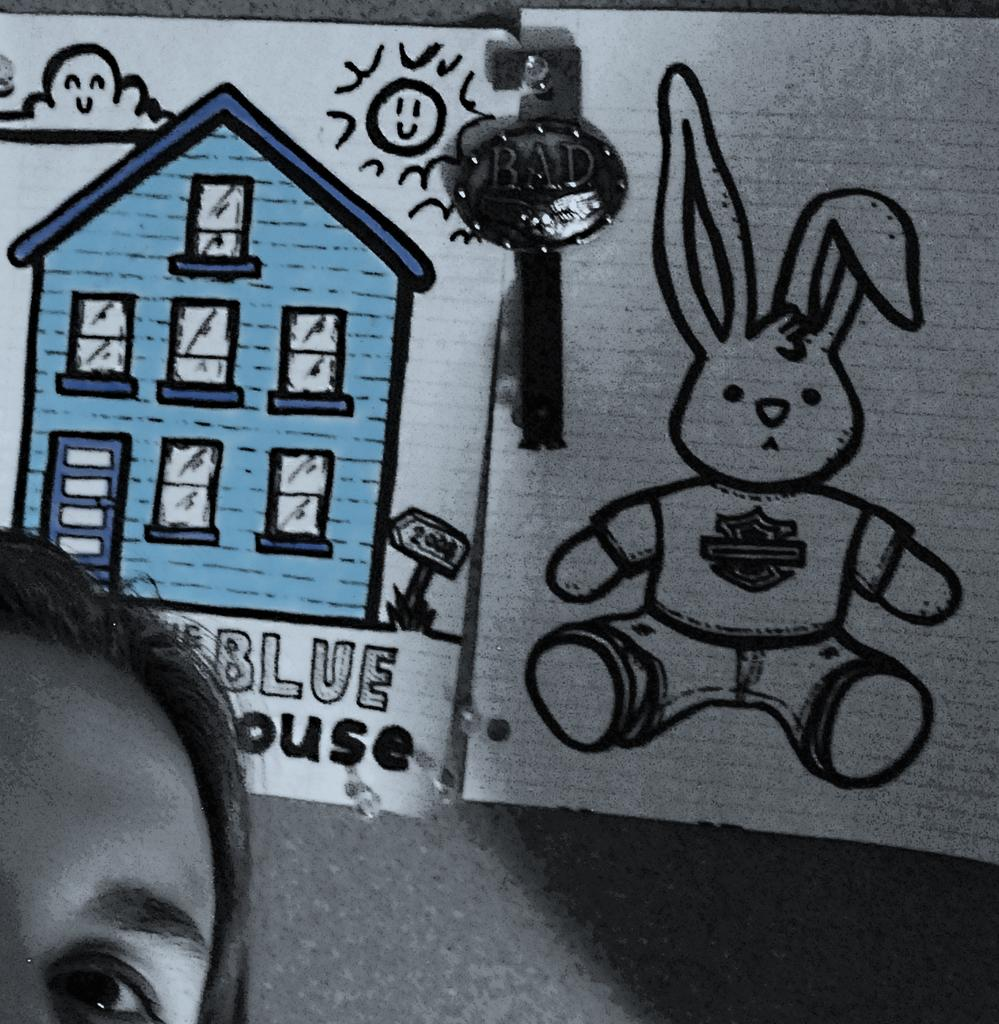What type of items are attached to the wall in the image? There are papers with drawings in the image. How are the papers with drawings displayed on the wall? The papers are attached to the wall. What other object can be seen in the image? There is an object that resembles a key in the image. Can you describe the person's face visible on the left side of the image? A person's face is visible on the left side of the image. What type of necklace is the person wearing in the image? There is no necklace visible in the image; only a person's face visible on the left side of the image. 